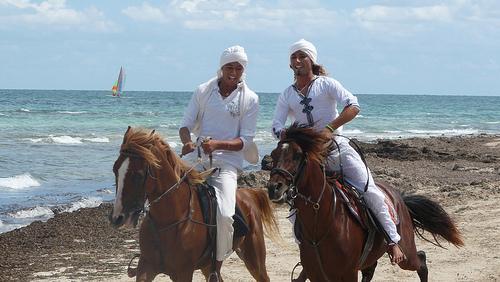How many horses are there?
Give a very brief answer. 2. 